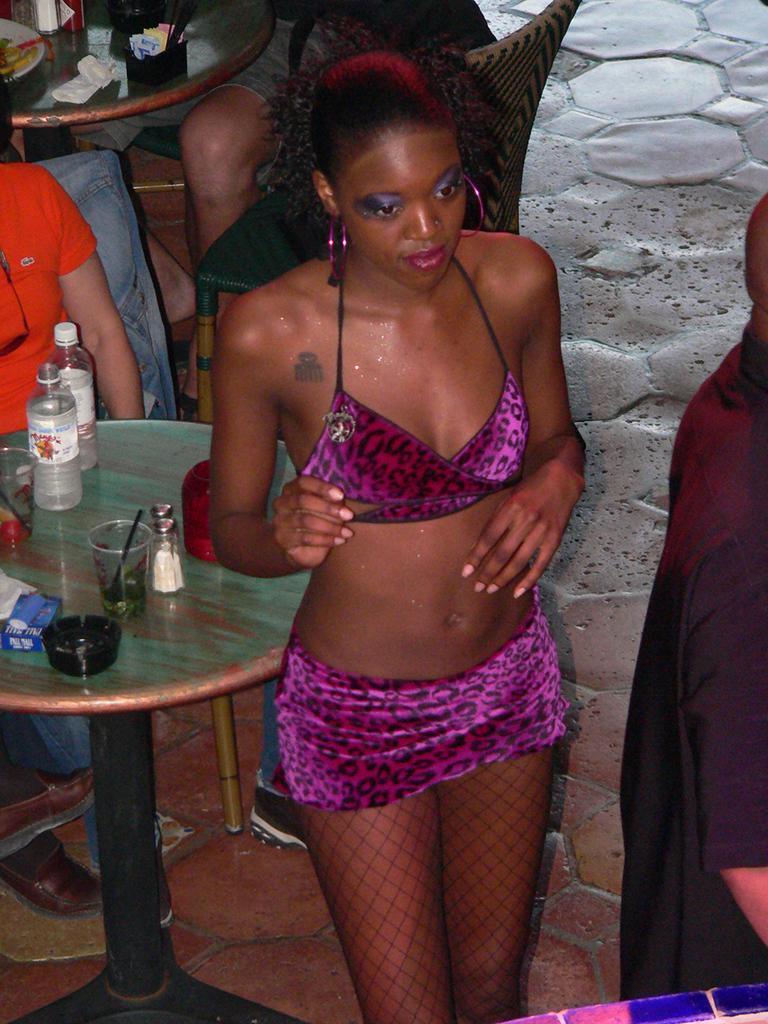Please provide a concise description of this image. In this picture we can see a woman standing near to the table and on the table we can see bottles, drinking glasses, bowl. We can see persons sitting on the chairs. 